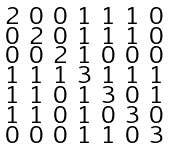Convert formula to latex. <formula><loc_0><loc_0><loc_500><loc_500>\begin{smallmatrix} 2 & 0 & 0 & 1 & 1 & 1 & 0 \\ 0 & 2 & 0 & 1 & 1 & 1 & 0 \\ 0 & 0 & 2 & 1 & 0 & 0 & 0 \\ 1 & 1 & 1 & 3 & 1 & 1 & 1 \\ 1 & 1 & 0 & 1 & 3 & 0 & 1 \\ 1 & 1 & 0 & 1 & 0 & 3 & 0 \\ 0 & 0 & 0 & 1 & 1 & 0 & 3 \end{smallmatrix}</formula> 